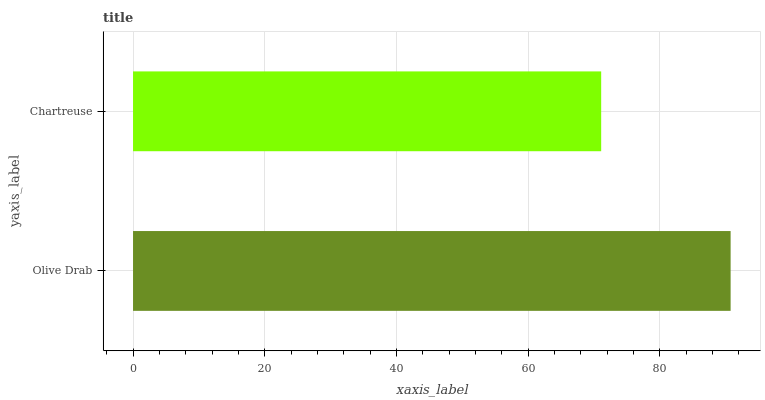Is Chartreuse the minimum?
Answer yes or no. Yes. Is Olive Drab the maximum?
Answer yes or no. Yes. Is Chartreuse the maximum?
Answer yes or no. No. Is Olive Drab greater than Chartreuse?
Answer yes or no. Yes. Is Chartreuse less than Olive Drab?
Answer yes or no. Yes. Is Chartreuse greater than Olive Drab?
Answer yes or no. No. Is Olive Drab less than Chartreuse?
Answer yes or no. No. Is Olive Drab the high median?
Answer yes or no. Yes. Is Chartreuse the low median?
Answer yes or no. Yes. Is Chartreuse the high median?
Answer yes or no. No. Is Olive Drab the low median?
Answer yes or no. No. 